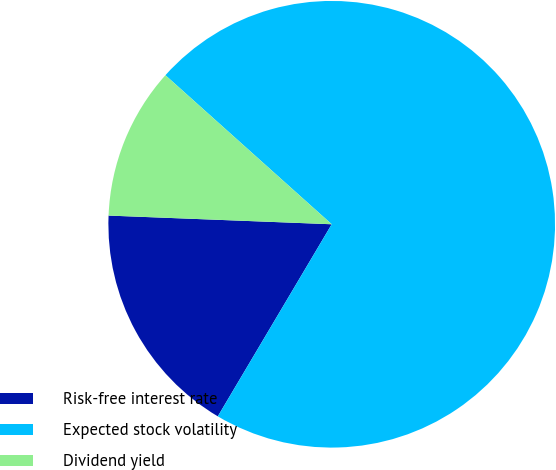<chart> <loc_0><loc_0><loc_500><loc_500><pie_chart><fcel>Risk-free interest rate<fcel>Expected stock volatility<fcel>Dividend yield<nl><fcel>17.1%<fcel>71.89%<fcel>11.01%<nl></chart> 